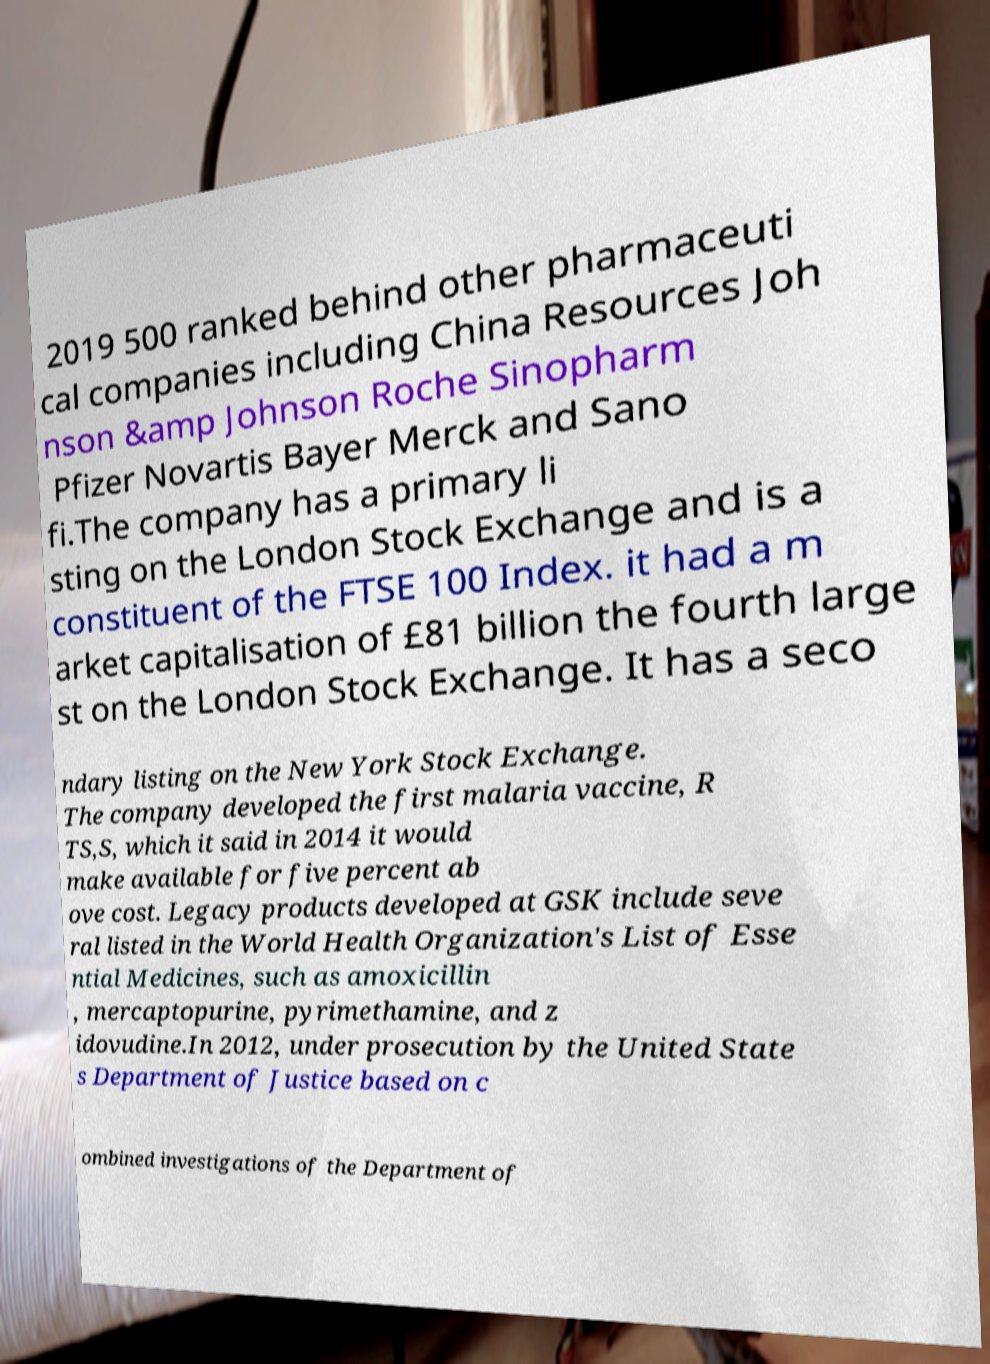Could you extract and type out the text from this image? 2019 500 ranked behind other pharmaceuti cal companies including China Resources Joh nson &amp Johnson Roche Sinopharm Pfizer Novartis Bayer Merck and Sano fi.The company has a primary li sting on the London Stock Exchange and is a constituent of the FTSE 100 Index. it had a m arket capitalisation of £81 billion the fourth large st on the London Stock Exchange. It has a seco ndary listing on the New York Stock Exchange. The company developed the first malaria vaccine, R TS,S, which it said in 2014 it would make available for five percent ab ove cost. Legacy products developed at GSK include seve ral listed in the World Health Organization's List of Esse ntial Medicines, such as amoxicillin , mercaptopurine, pyrimethamine, and z idovudine.In 2012, under prosecution by the United State s Department of Justice based on c ombined investigations of the Department of 